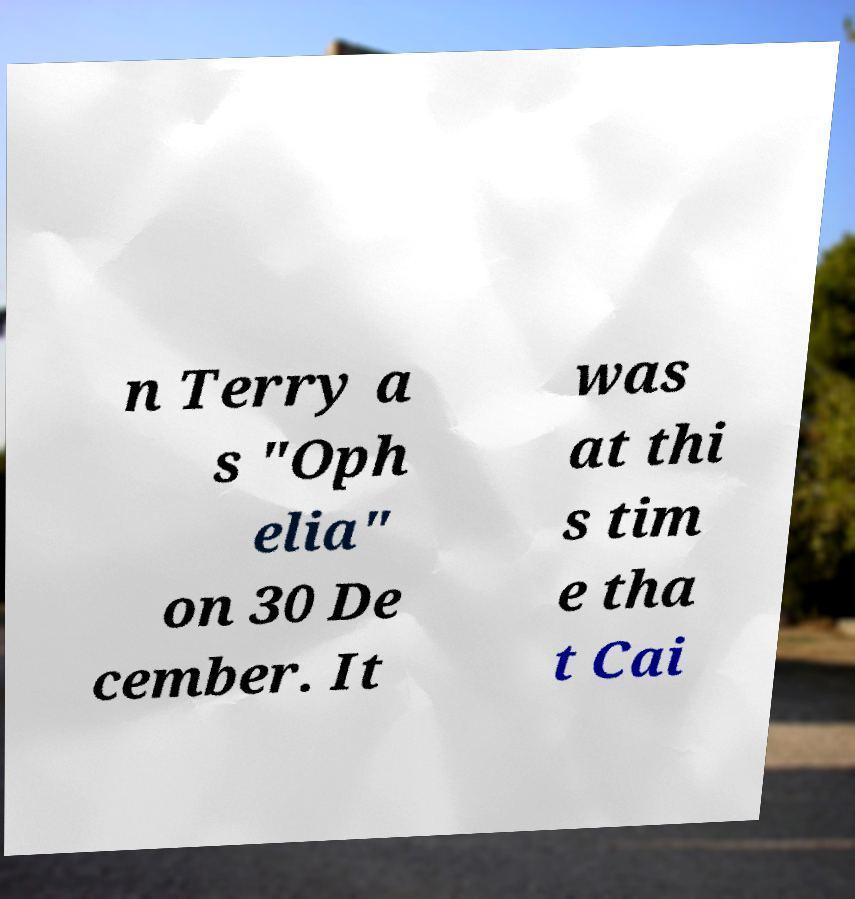Can you read and provide the text displayed in the image?This photo seems to have some interesting text. Can you extract and type it out for me? n Terry a s "Oph elia" on 30 De cember. It was at thi s tim e tha t Cai 